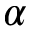<formula> <loc_0><loc_0><loc_500><loc_500>\alpha</formula> 